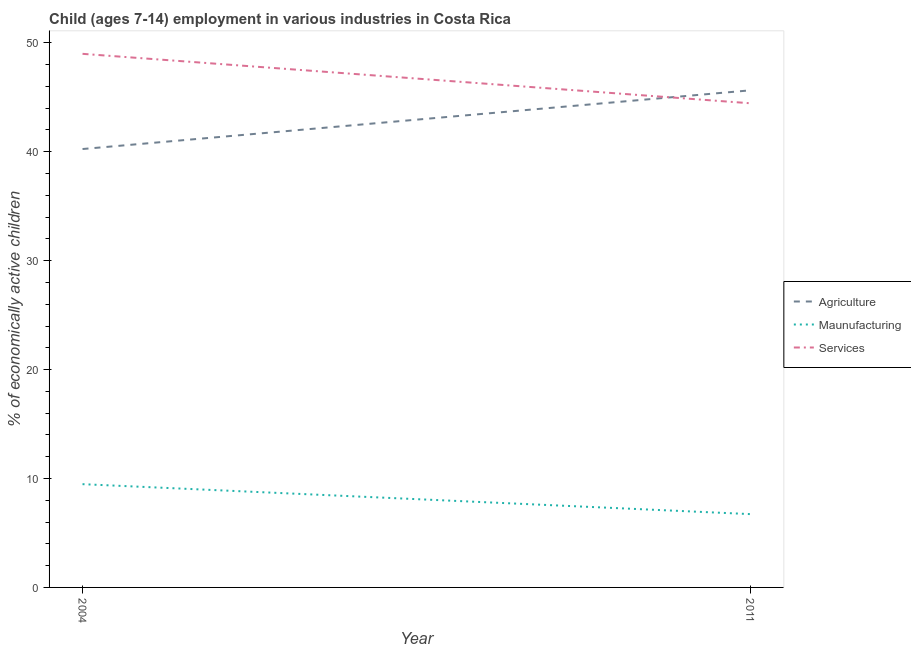Does the line corresponding to percentage of economically active children in manufacturing intersect with the line corresponding to percentage of economically active children in agriculture?
Provide a short and direct response. No. Is the number of lines equal to the number of legend labels?
Keep it short and to the point. Yes. What is the percentage of economically active children in services in 2011?
Offer a very short reply. 44.45. Across all years, what is the maximum percentage of economically active children in services?
Give a very brief answer. 48.99. Across all years, what is the minimum percentage of economically active children in services?
Give a very brief answer. 44.45. What is the total percentage of economically active children in services in the graph?
Your answer should be very brief. 93.44. What is the difference between the percentage of economically active children in agriculture in 2004 and that in 2011?
Provide a succinct answer. -5.39. What is the difference between the percentage of economically active children in services in 2011 and the percentage of economically active children in agriculture in 2004?
Offer a terse response. 4.2. What is the average percentage of economically active children in services per year?
Offer a terse response. 46.72. In the year 2004, what is the difference between the percentage of economically active children in agriculture and percentage of economically active children in services?
Provide a short and direct response. -8.74. In how many years, is the percentage of economically active children in manufacturing greater than 32 %?
Provide a succinct answer. 0. What is the ratio of the percentage of economically active children in agriculture in 2004 to that in 2011?
Provide a short and direct response. 0.88. Is it the case that in every year, the sum of the percentage of economically active children in agriculture and percentage of economically active children in manufacturing is greater than the percentage of economically active children in services?
Your answer should be very brief. Yes. Is the percentage of economically active children in services strictly less than the percentage of economically active children in manufacturing over the years?
Offer a terse response. No. How many lines are there?
Give a very brief answer. 3. Are the values on the major ticks of Y-axis written in scientific E-notation?
Your answer should be compact. No. Does the graph contain any zero values?
Provide a short and direct response. No. Does the graph contain grids?
Your answer should be compact. No. How are the legend labels stacked?
Your answer should be very brief. Vertical. What is the title of the graph?
Provide a succinct answer. Child (ages 7-14) employment in various industries in Costa Rica. What is the label or title of the X-axis?
Provide a short and direct response. Year. What is the label or title of the Y-axis?
Offer a very short reply. % of economically active children. What is the % of economically active children of Agriculture in 2004?
Make the answer very short. 40.25. What is the % of economically active children of Maunufacturing in 2004?
Your answer should be compact. 9.48. What is the % of economically active children of Services in 2004?
Offer a very short reply. 48.99. What is the % of economically active children of Agriculture in 2011?
Offer a terse response. 45.64. What is the % of economically active children in Maunufacturing in 2011?
Ensure brevity in your answer.  6.73. What is the % of economically active children of Services in 2011?
Make the answer very short. 44.45. Across all years, what is the maximum % of economically active children in Agriculture?
Keep it short and to the point. 45.64. Across all years, what is the maximum % of economically active children in Maunufacturing?
Your response must be concise. 9.48. Across all years, what is the maximum % of economically active children in Services?
Offer a terse response. 48.99. Across all years, what is the minimum % of economically active children in Agriculture?
Offer a very short reply. 40.25. Across all years, what is the minimum % of economically active children in Maunufacturing?
Offer a terse response. 6.73. Across all years, what is the minimum % of economically active children of Services?
Give a very brief answer. 44.45. What is the total % of economically active children of Agriculture in the graph?
Offer a very short reply. 85.89. What is the total % of economically active children of Maunufacturing in the graph?
Provide a succinct answer. 16.21. What is the total % of economically active children of Services in the graph?
Your response must be concise. 93.44. What is the difference between the % of economically active children in Agriculture in 2004 and that in 2011?
Your response must be concise. -5.39. What is the difference between the % of economically active children of Maunufacturing in 2004 and that in 2011?
Give a very brief answer. 2.75. What is the difference between the % of economically active children of Services in 2004 and that in 2011?
Your answer should be very brief. 4.54. What is the difference between the % of economically active children of Agriculture in 2004 and the % of economically active children of Maunufacturing in 2011?
Make the answer very short. 33.52. What is the difference between the % of economically active children in Maunufacturing in 2004 and the % of economically active children in Services in 2011?
Provide a short and direct response. -34.97. What is the average % of economically active children in Agriculture per year?
Give a very brief answer. 42.95. What is the average % of economically active children of Maunufacturing per year?
Provide a short and direct response. 8.11. What is the average % of economically active children in Services per year?
Keep it short and to the point. 46.72. In the year 2004, what is the difference between the % of economically active children of Agriculture and % of economically active children of Maunufacturing?
Ensure brevity in your answer.  30.77. In the year 2004, what is the difference between the % of economically active children in Agriculture and % of economically active children in Services?
Give a very brief answer. -8.74. In the year 2004, what is the difference between the % of economically active children in Maunufacturing and % of economically active children in Services?
Keep it short and to the point. -39.51. In the year 2011, what is the difference between the % of economically active children of Agriculture and % of economically active children of Maunufacturing?
Give a very brief answer. 38.91. In the year 2011, what is the difference between the % of economically active children of Agriculture and % of economically active children of Services?
Ensure brevity in your answer.  1.19. In the year 2011, what is the difference between the % of economically active children of Maunufacturing and % of economically active children of Services?
Provide a succinct answer. -37.72. What is the ratio of the % of economically active children in Agriculture in 2004 to that in 2011?
Offer a terse response. 0.88. What is the ratio of the % of economically active children in Maunufacturing in 2004 to that in 2011?
Your answer should be compact. 1.41. What is the ratio of the % of economically active children in Services in 2004 to that in 2011?
Make the answer very short. 1.1. What is the difference between the highest and the second highest % of economically active children in Agriculture?
Your response must be concise. 5.39. What is the difference between the highest and the second highest % of economically active children in Maunufacturing?
Give a very brief answer. 2.75. What is the difference between the highest and the second highest % of economically active children of Services?
Keep it short and to the point. 4.54. What is the difference between the highest and the lowest % of economically active children in Agriculture?
Make the answer very short. 5.39. What is the difference between the highest and the lowest % of economically active children of Maunufacturing?
Offer a terse response. 2.75. What is the difference between the highest and the lowest % of economically active children of Services?
Give a very brief answer. 4.54. 